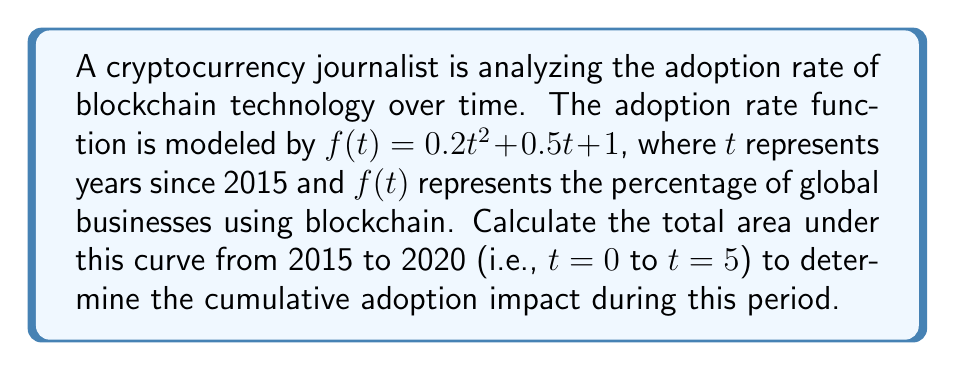Help me with this question. To calculate the area under the curve, we need to use a definite integral. The steps are as follows:

1) The function is $f(t) = 0.2t^2 + 0.5t + 1$
2) We need to integrate from $t=0$ to $t=5$

3) Set up the definite integral:
   $$\int_0^5 (0.2t^2 + 0.5t + 1) dt$$

4) Integrate each term:
   $$\left[ \frac{0.2t^3}{3} + \frac{0.5t^2}{2} + t \right]_0^5$$

5) Evaluate the integral at the upper and lower bounds:
   $$\left( \frac{0.2(5^3)}{3} + \frac{0.5(5^2)}{2} + 5 \right) - \left( \frac{0.2(0^3)}{3} + \frac{0.5(0^2)}{2} + 0 \right)$$

6) Simplify:
   $$\left( \frac{25}{3} + \frac{25}{4} + 5 \right) - 0$$

7) Calculate:
   $$\frac{25}{3} + \frac{25}{4} + 5 = 8.33 + 6.25 + 5 = 19.58$$

The area under the curve represents the cumulative adoption impact of blockchain technology from 2015 to 2020.
Answer: 19.58 